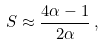<formula> <loc_0><loc_0><loc_500><loc_500>S \approx \frac { 4 \alpha - 1 } { 2 \alpha } \, ,</formula> 